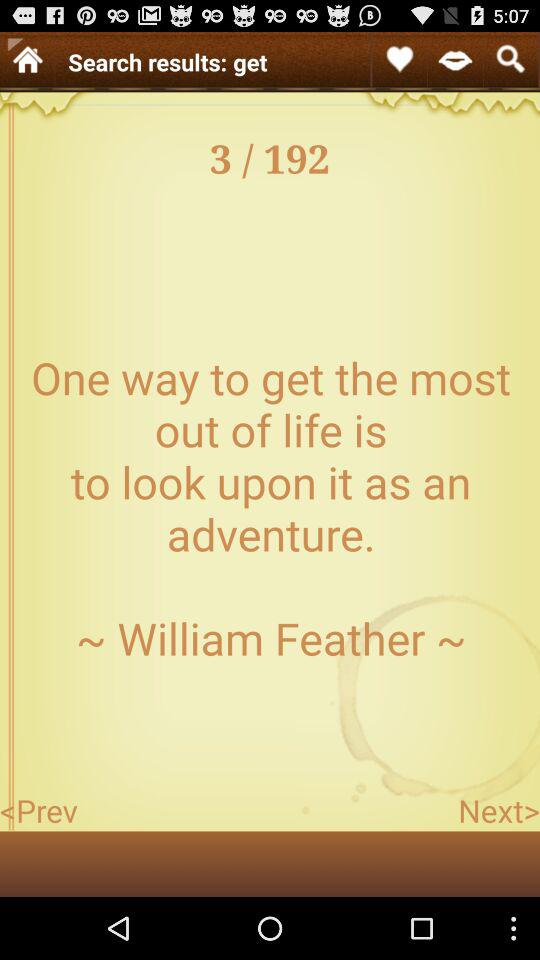Which page am I on? You are on page 3. 